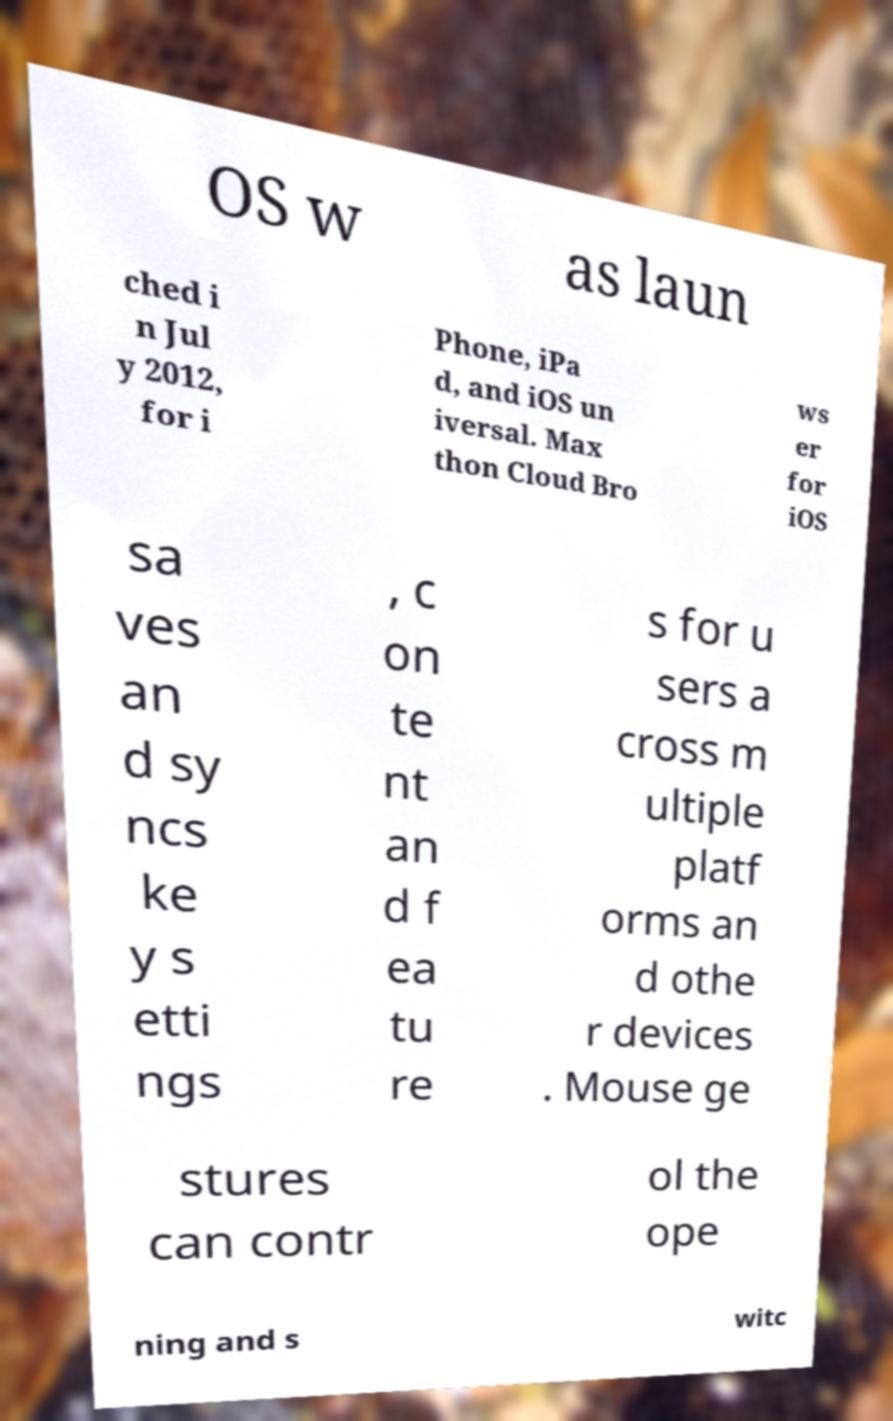Please read and relay the text visible in this image. What does it say? OS w as laun ched i n Jul y 2012, for i Phone, iPa d, and iOS un iversal. Max thon Cloud Bro ws er for iOS sa ves an d sy ncs ke y s etti ngs , c on te nt an d f ea tu re s for u sers a cross m ultiple platf orms an d othe r devices . Mouse ge stures can contr ol the ope ning and s witc 